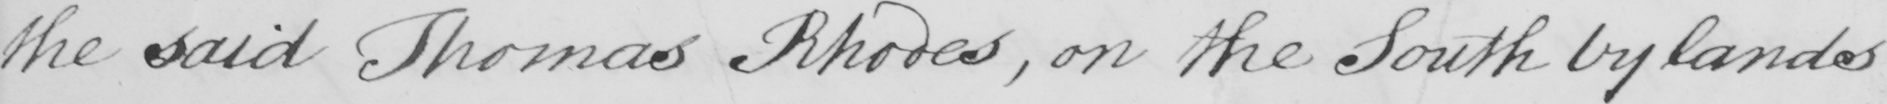Can you tell me what this handwritten text says? the said Thomas Rhodes , on the South by lands 